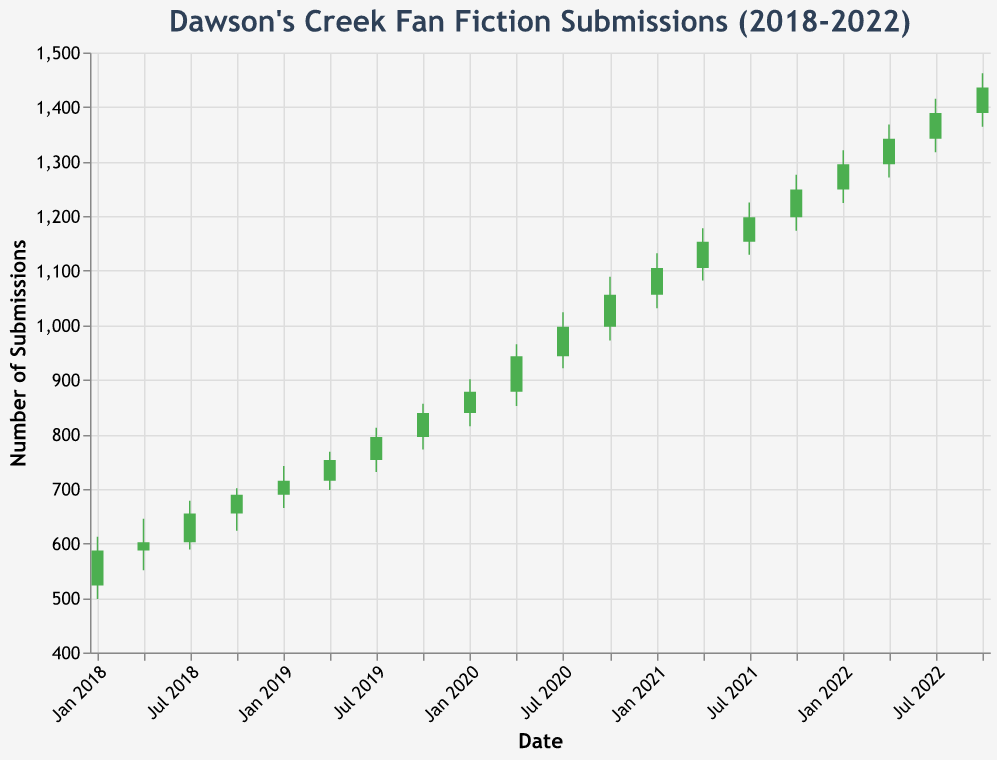What is the title of the figure? The title is located at the top of the chart and describes what the chart is about.
Answer: Dawson's Creek Fan Fiction Submissions (2018-2022) How many data points are plotted on the chart? Each time point has an Open, High, Low, and Close value, and there are a total of 19 points ranging from Jan 2018 to Oct 2022.
Answer: 19 Between which two dates did the number of submissions increase the most? By comparing the Close value of each date with the next, we can see the largest increase happens between Oct 2021 (1249) and Jan 2022 (1295), showing an increase of 46 submissions.
Answer: Between Oct 2021 and Jan 2022 What is the highest number of submissions recorded in the chart? To find this, look at the High values across all points which show the peak values reached.
Answer: 1462 Between Jul 2020 and Oct 2020, was there an increase or decrease in the Close value? By comparing the Close value of Jul 2020 (997) and Oct 2020 (1056), we can see the Close value increased.
Answer: Increase What was the Open value in April 2018? The Open value for each date is given directly in the data series; look for Apr 2018.
Answer: 587 Calculate the average High value for the year 2022. Sum the High values for Jan 2022 (1321), Apr 2022 (1368), Jul 2022 (1415), and Oct 2022 (1462), then divide by 4.
Answer: 1391.5 Was there any instance where the Close value was lower than the Open value? Check for any occurrences where the Close is less than the Open in the dataset. Apr 2018, for instance, had an Open of 587 and a Close of 602.
Answer: No During which month and year did the submissions first surpass 1000? Compare the High values across all dates to see the point where it exceeds 1000. It happens in Jul 2020 (1024).
Answer: Jul 2020 Identify the period where the Close values consistently increased for the longest span of time. Look for the longest consecutive period where the Close for each subsequent time point is higher than the previous. This happens from Jan 2018 (587) to Oct 2022 (1436).
Answer: Jan 2018 to Oct 2022 